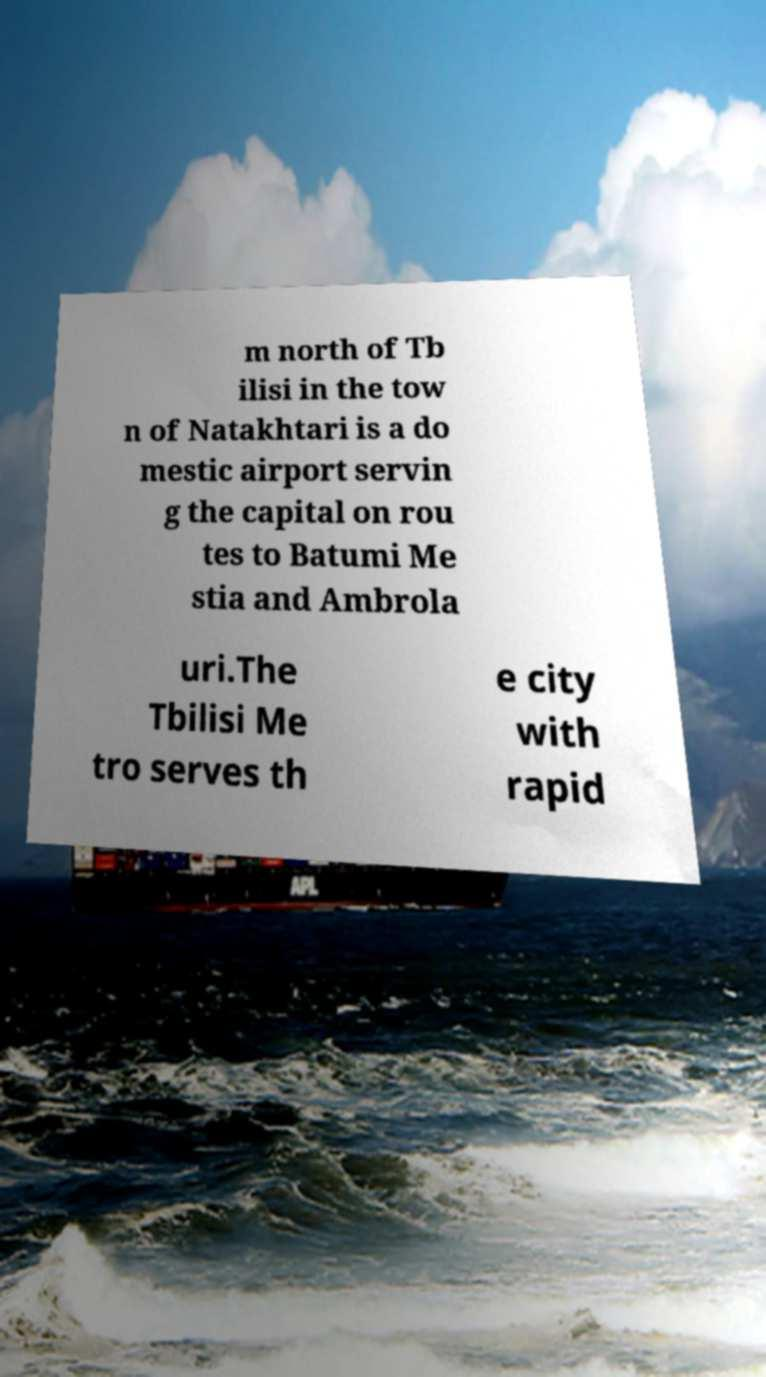Could you extract and type out the text from this image? m north of Tb ilisi in the tow n of Natakhtari is a do mestic airport servin g the capital on rou tes to Batumi Me stia and Ambrola uri.The Tbilisi Me tro serves th e city with rapid 